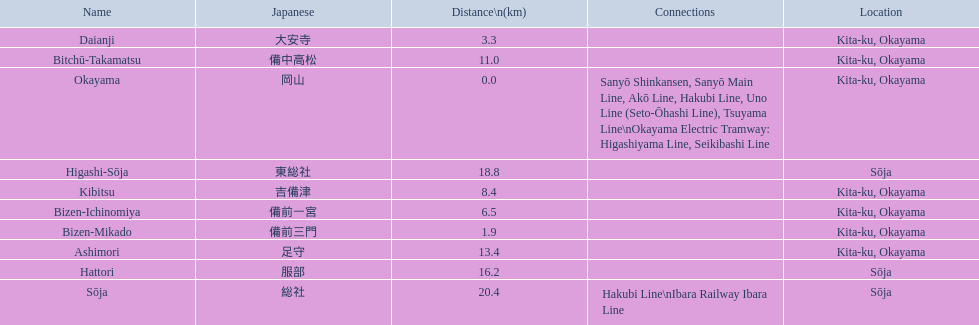What are all the stations on the kibi line? Okayama, Bizen-Mikado, Daianji, Bizen-Ichinomiya, Kibitsu, Bitchū-Takamatsu, Ashimori, Hattori, Higashi-Sōja, Sōja. What are the distances of these stations from the start of the line? 0.0, 1.9, 3.3, 6.5, 8.4, 11.0, 13.4, 16.2, 18.8, 20.4. Of these, which is larger than 1 km? 1.9, 3.3, 6.5, 8.4, 11.0, 13.4, 16.2, 18.8, 20.4. Of these, which is smaller than 2 km? 1.9. Which station is this distance from the start of the line? Bizen-Mikado. 